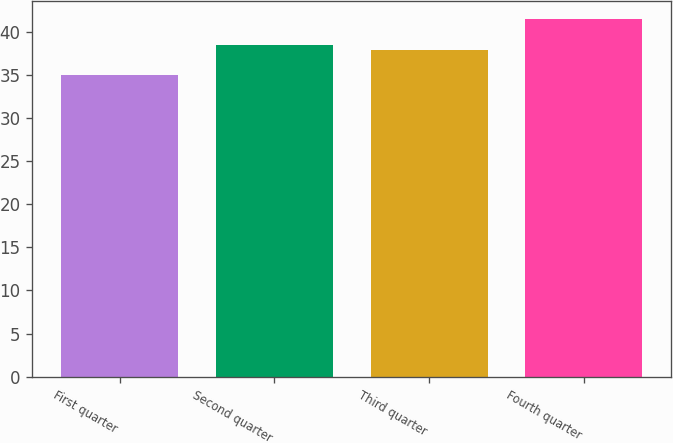<chart> <loc_0><loc_0><loc_500><loc_500><bar_chart><fcel>First quarter<fcel>Second quarter<fcel>Third quarter<fcel>Fourth quarter<nl><fcel>35.03<fcel>38.54<fcel>37.89<fcel>41.5<nl></chart> 